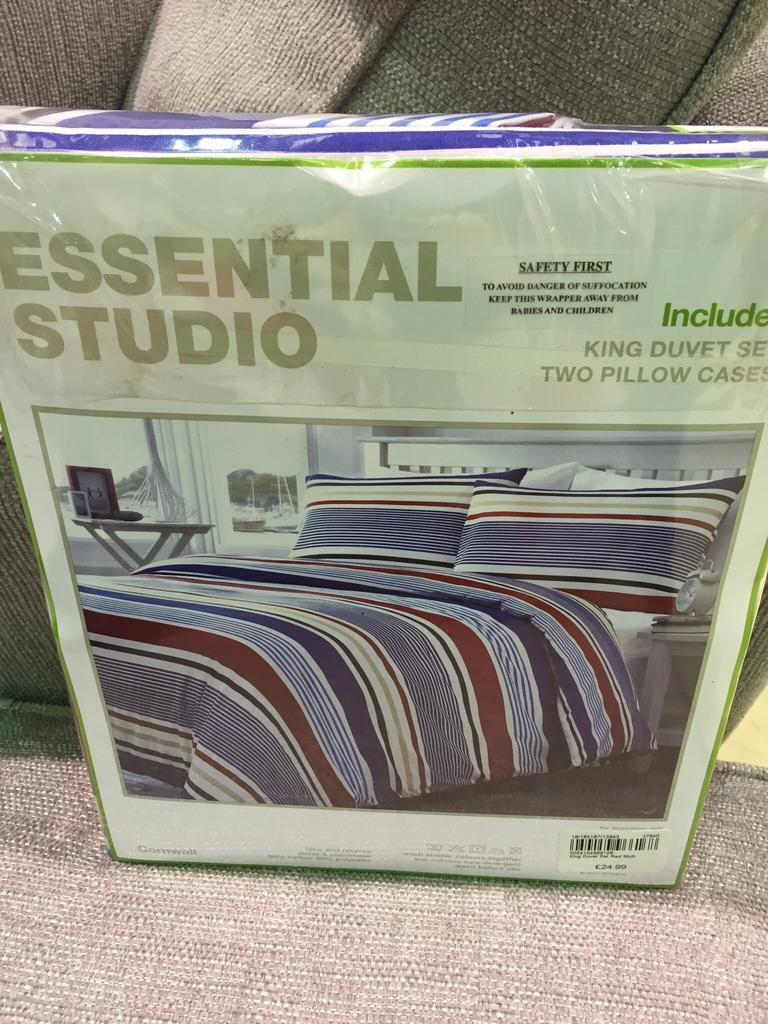What is the main object in the image? There is a box in the image. What is depicted on the box? The box has a photo of a bed on it. What type of pencil is being used to draw the feast on the box? There is no pencil or feast depicted on the box; it only has a photo of a bed. What shape is the bed on the box? The provided facts do not mention the shape of the bed on the box, only that there is a photo of a bed. 